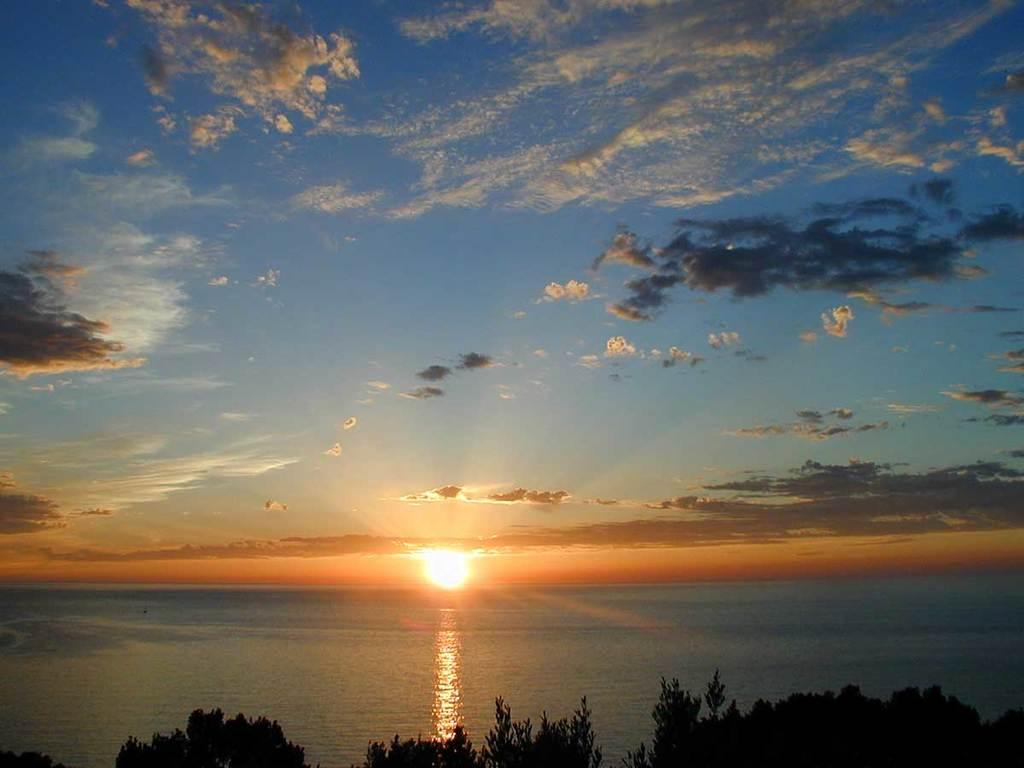What type of living organisms can be seen in the image? Plants can be seen in the image. What natural element is visible in the image? Water is visible in the image. What is the source of light in the image? Sunlight is present in the image. What is visible in the background of the image? The sky is visible in the image. Where might this image have been taken? The image may have been taken near a lake, given the presence of water and plants. What word is being used to describe the plants in the image? There is no specific word being used to describe the plants in the image; they are simply referred to as "plants." 